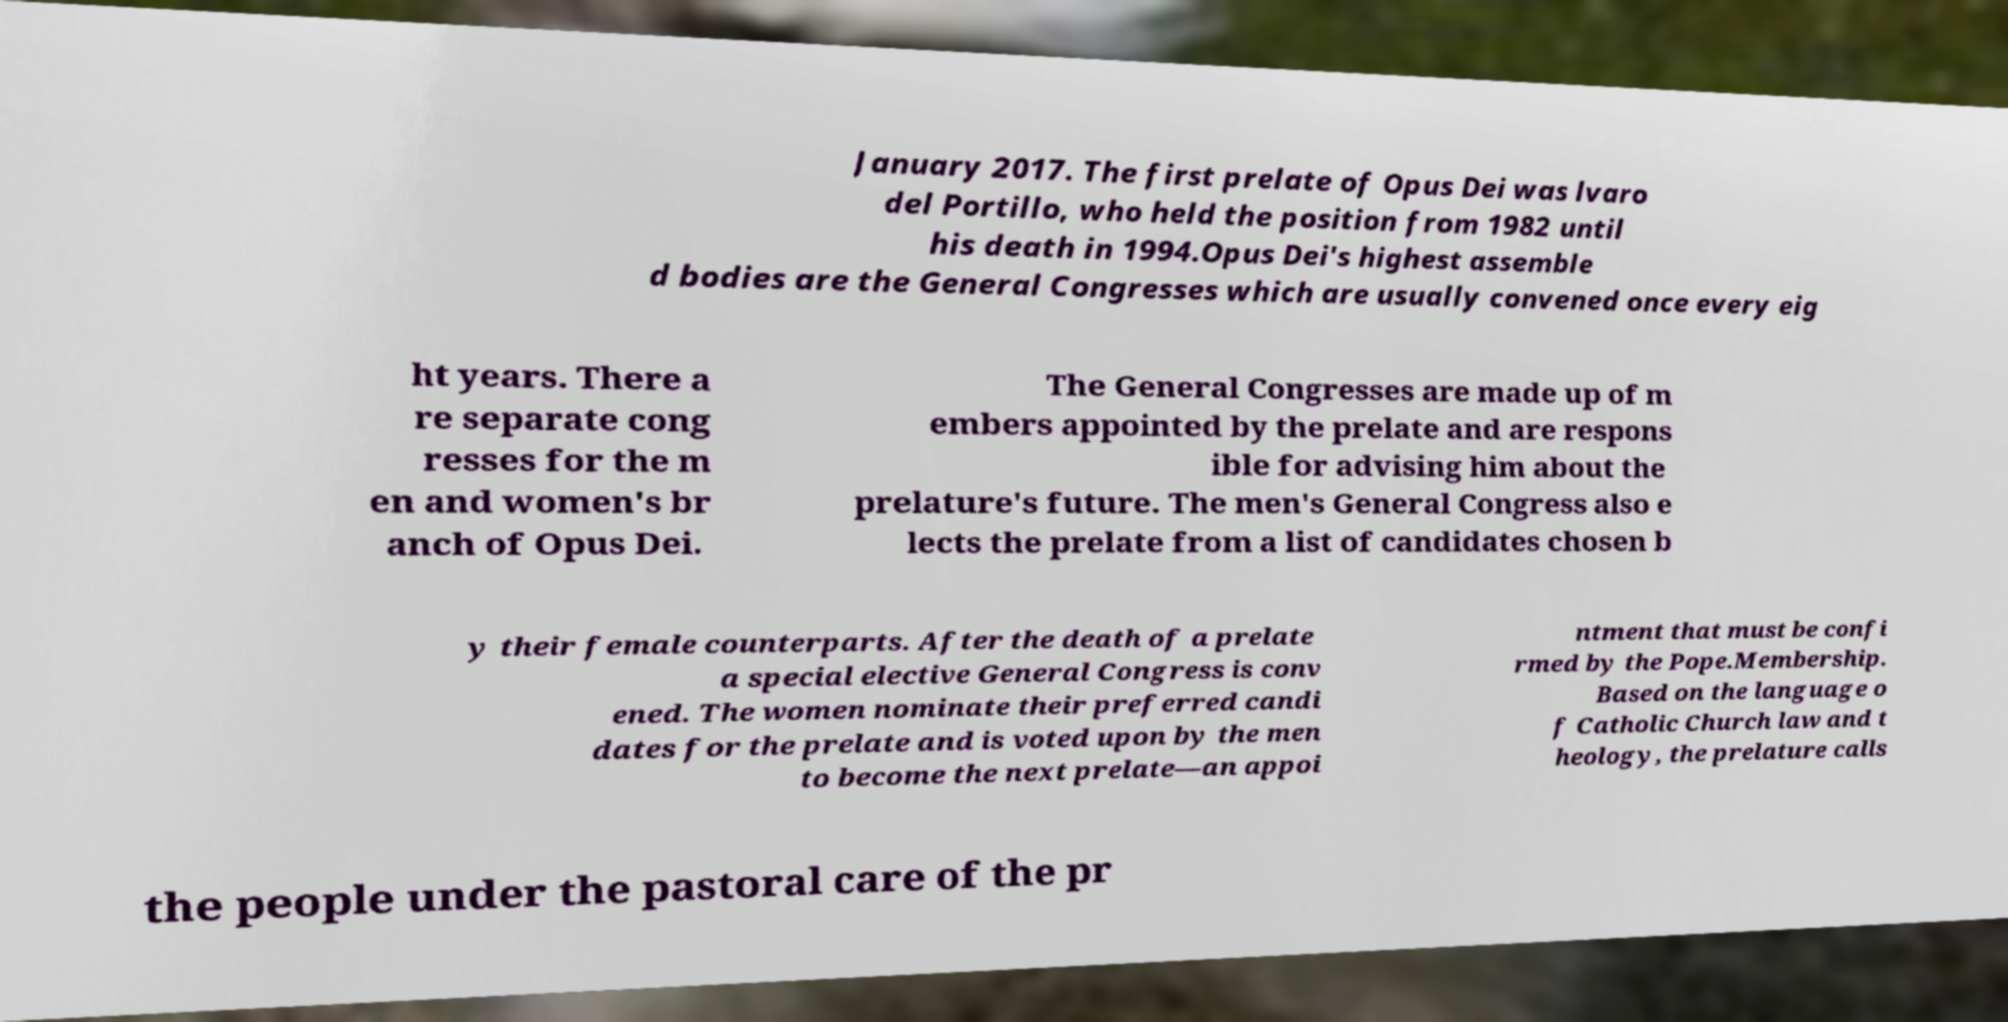Could you assist in decoding the text presented in this image and type it out clearly? January 2017. The first prelate of Opus Dei was lvaro del Portillo, who held the position from 1982 until his death in 1994.Opus Dei's highest assemble d bodies are the General Congresses which are usually convened once every eig ht years. There a re separate cong resses for the m en and women's br anch of Opus Dei. The General Congresses are made up of m embers appointed by the prelate and are respons ible for advising him about the prelature's future. The men's General Congress also e lects the prelate from a list of candidates chosen b y their female counterparts. After the death of a prelate a special elective General Congress is conv ened. The women nominate their preferred candi dates for the prelate and is voted upon by the men to become the next prelate—an appoi ntment that must be confi rmed by the Pope.Membership. Based on the language o f Catholic Church law and t heology, the prelature calls the people under the pastoral care of the pr 